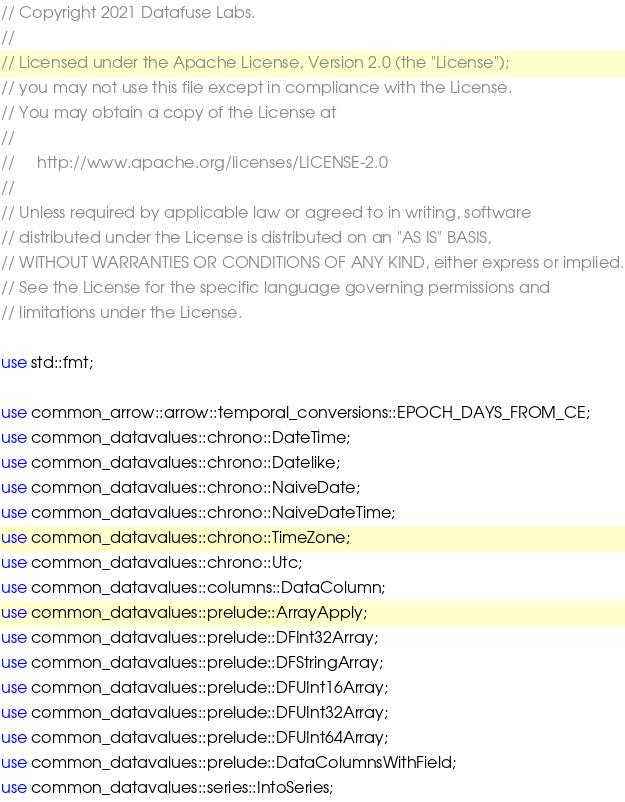Convert code to text. <code><loc_0><loc_0><loc_500><loc_500><_Rust_>// Copyright 2021 Datafuse Labs.
//
// Licensed under the Apache License, Version 2.0 (the "License");
// you may not use this file except in compliance with the License.
// You may obtain a copy of the License at
//
//     http://www.apache.org/licenses/LICENSE-2.0
//
// Unless required by applicable law or agreed to in writing, software
// distributed under the License is distributed on an "AS IS" BASIS,
// WITHOUT WARRANTIES OR CONDITIONS OF ANY KIND, either express or implied.
// See the License for the specific language governing permissions and
// limitations under the License.

use std::fmt;

use common_arrow::arrow::temporal_conversions::EPOCH_DAYS_FROM_CE;
use common_datavalues::chrono::DateTime;
use common_datavalues::chrono::Datelike;
use common_datavalues::chrono::NaiveDate;
use common_datavalues::chrono::NaiveDateTime;
use common_datavalues::chrono::TimeZone;
use common_datavalues::chrono::Utc;
use common_datavalues::columns::DataColumn;
use common_datavalues::prelude::ArrayApply;
use common_datavalues::prelude::DFInt32Array;
use common_datavalues::prelude::DFStringArray;
use common_datavalues::prelude::DFUInt16Array;
use common_datavalues::prelude::DFUInt32Array;
use common_datavalues::prelude::DFUInt64Array;
use common_datavalues::prelude::DataColumnsWithField;
use common_datavalues::series::IntoSeries;</code> 